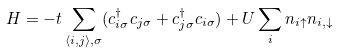<formula> <loc_0><loc_0><loc_500><loc_500>H = - t \sum _ { \langle i , j \rangle , \sigma } ( c ^ { \dagger } _ { i \sigma } c _ { j \sigma } + c ^ { \dagger } _ { j \sigma } c _ { i \sigma } ) + U \sum _ { i } n _ { i \uparrow } n _ { i , \downarrow }</formula> 